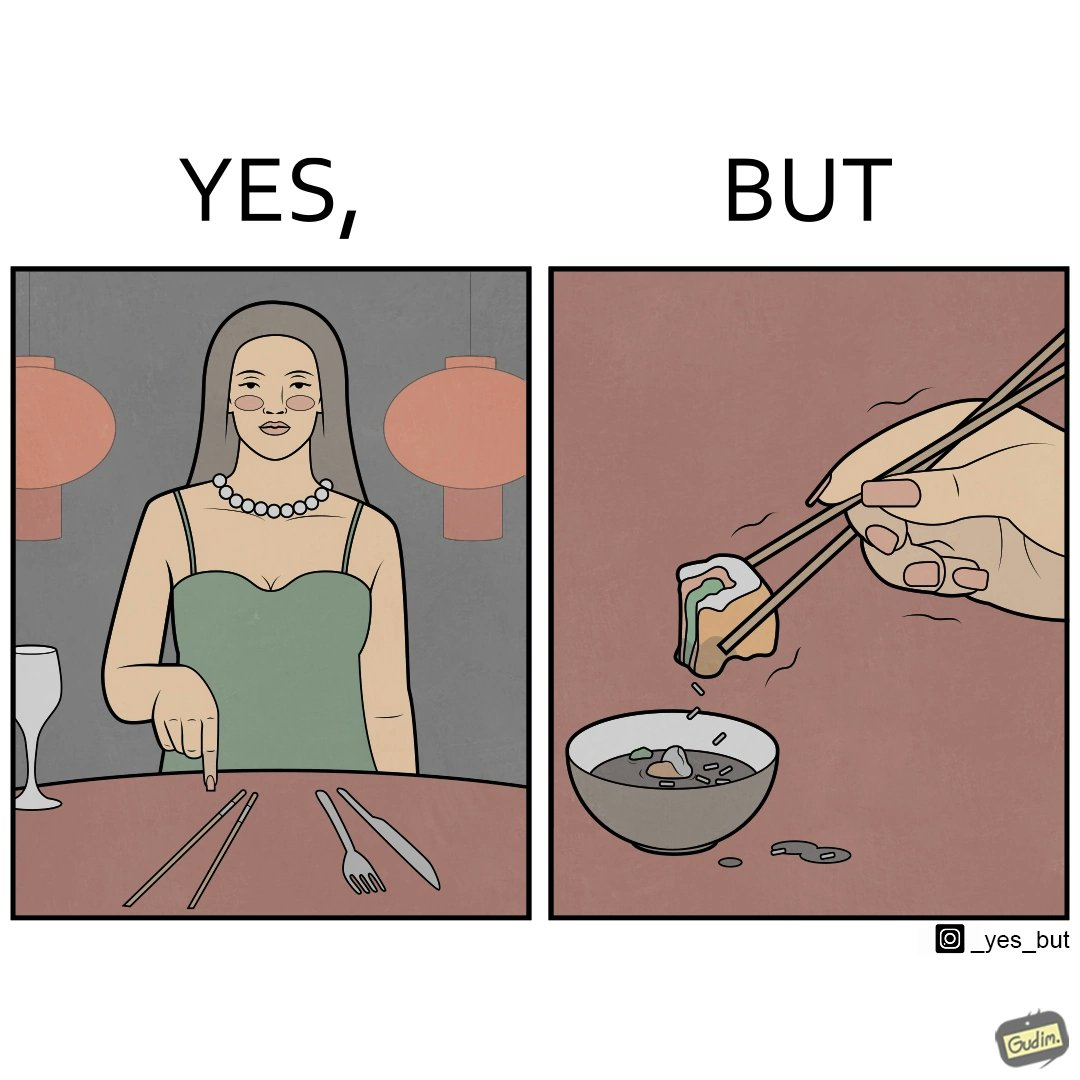What makes this image funny or satirical? The image is satirical because even thought the woman is not able to eat food with chopstick properly, she chooses it over fork and knife to look sophisticaed. 